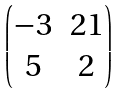<formula> <loc_0><loc_0><loc_500><loc_500>\begin{pmatrix} - 3 & 2 1 \\ 5 & 2 \end{pmatrix}</formula> 